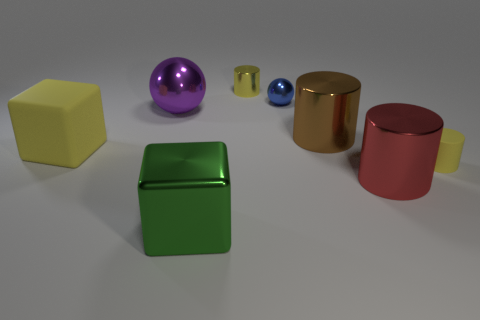Add 1 large purple balls. How many objects exist? 9 Subtract all balls. How many objects are left? 6 Subtract 0 purple cylinders. How many objects are left? 8 Subtract all large cyan cubes. Subtract all purple things. How many objects are left? 7 Add 4 tiny yellow shiny cylinders. How many tiny yellow shiny cylinders are left? 5 Add 1 cubes. How many cubes exist? 3 